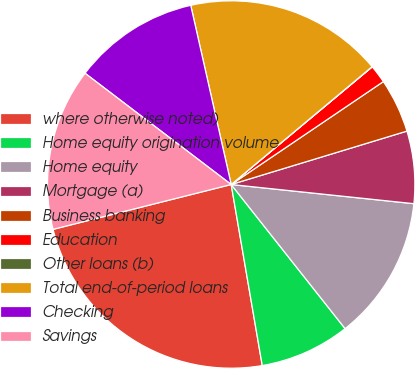<chart> <loc_0><loc_0><loc_500><loc_500><pie_chart><fcel>where otherwise noted)<fcel>Home equity origination volume<fcel>Home equity<fcel>Mortgage (a)<fcel>Business banking<fcel>Education<fcel>Other loans (b)<fcel>Total end-of-period loans<fcel>Checking<fcel>Savings<nl><fcel>23.78%<fcel>7.94%<fcel>12.69%<fcel>6.36%<fcel>4.77%<fcel>1.6%<fcel>0.02%<fcel>17.45%<fcel>11.11%<fcel>14.28%<nl></chart> 